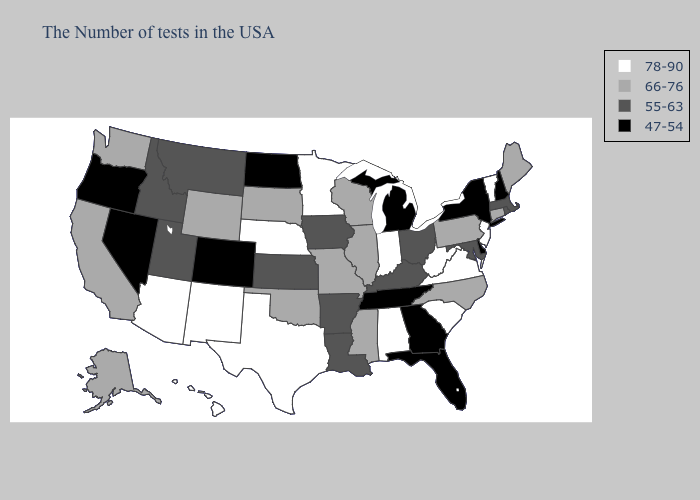Does North Dakota have a lower value than Connecticut?
Quick response, please. Yes. Does South Carolina have the lowest value in the USA?
Short answer required. No. Does Iowa have a lower value than Maryland?
Write a very short answer. No. What is the highest value in the MidWest ?
Write a very short answer. 78-90. What is the value of Maine?
Short answer required. 66-76. What is the value of Maryland?
Concise answer only. 55-63. What is the lowest value in the West?
Give a very brief answer. 47-54. What is the lowest value in states that border Maryland?
Concise answer only. 47-54. Name the states that have a value in the range 66-76?
Concise answer only. Maine, Connecticut, Pennsylvania, North Carolina, Wisconsin, Illinois, Mississippi, Missouri, Oklahoma, South Dakota, Wyoming, California, Washington, Alaska. What is the lowest value in the MidWest?
Short answer required. 47-54. What is the value of Delaware?
Keep it brief. 47-54. What is the value of New Hampshire?
Answer briefly. 47-54. Among the states that border Arkansas , which have the highest value?
Concise answer only. Texas. Which states have the highest value in the USA?
Short answer required. Vermont, New Jersey, Virginia, South Carolina, West Virginia, Indiana, Alabama, Minnesota, Nebraska, Texas, New Mexico, Arizona, Hawaii. Among the states that border Indiana , does Michigan have the lowest value?
Give a very brief answer. Yes. 